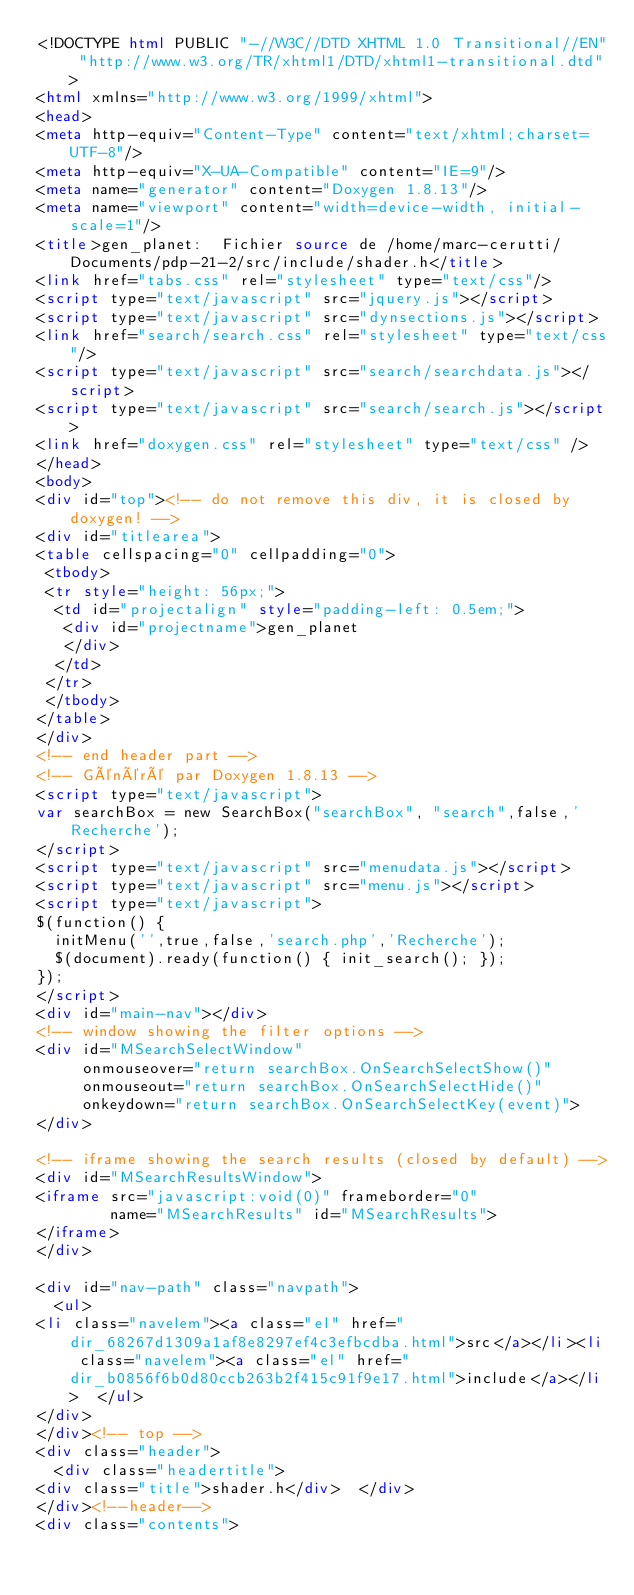<code> <loc_0><loc_0><loc_500><loc_500><_HTML_><!DOCTYPE html PUBLIC "-//W3C//DTD XHTML 1.0 Transitional//EN" "http://www.w3.org/TR/xhtml1/DTD/xhtml1-transitional.dtd">
<html xmlns="http://www.w3.org/1999/xhtml">
<head>
<meta http-equiv="Content-Type" content="text/xhtml;charset=UTF-8"/>
<meta http-equiv="X-UA-Compatible" content="IE=9"/>
<meta name="generator" content="Doxygen 1.8.13"/>
<meta name="viewport" content="width=device-width, initial-scale=1"/>
<title>gen_planet:  Fichier source de /home/marc-cerutti/Documents/pdp-21-2/src/include/shader.h</title>
<link href="tabs.css" rel="stylesheet" type="text/css"/>
<script type="text/javascript" src="jquery.js"></script>
<script type="text/javascript" src="dynsections.js"></script>
<link href="search/search.css" rel="stylesheet" type="text/css"/>
<script type="text/javascript" src="search/searchdata.js"></script>
<script type="text/javascript" src="search/search.js"></script>
<link href="doxygen.css" rel="stylesheet" type="text/css" />
</head>
<body>
<div id="top"><!-- do not remove this div, it is closed by doxygen! -->
<div id="titlearea">
<table cellspacing="0" cellpadding="0">
 <tbody>
 <tr style="height: 56px;">
  <td id="projectalign" style="padding-left: 0.5em;">
   <div id="projectname">gen_planet
   </div>
  </td>
 </tr>
 </tbody>
</table>
</div>
<!-- end header part -->
<!-- Généré par Doxygen 1.8.13 -->
<script type="text/javascript">
var searchBox = new SearchBox("searchBox", "search",false,'Recherche');
</script>
<script type="text/javascript" src="menudata.js"></script>
<script type="text/javascript" src="menu.js"></script>
<script type="text/javascript">
$(function() {
  initMenu('',true,false,'search.php','Recherche');
  $(document).ready(function() { init_search(); });
});
</script>
<div id="main-nav"></div>
<!-- window showing the filter options -->
<div id="MSearchSelectWindow"
     onmouseover="return searchBox.OnSearchSelectShow()"
     onmouseout="return searchBox.OnSearchSelectHide()"
     onkeydown="return searchBox.OnSearchSelectKey(event)">
</div>

<!-- iframe showing the search results (closed by default) -->
<div id="MSearchResultsWindow">
<iframe src="javascript:void(0)" frameborder="0" 
        name="MSearchResults" id="MSearchResults">
</iframe>
</div>

<div id="nav-path" class="navpath">
  <ul>
<li class="navelem"><a class="el" href="dir_68267d1309a1af8e8297ef4c3efbcdba.html">src</a></li><li class="navelem"><a class="el" href="dir_b0856f6b0d80ccb263b2f415c91f9e17.html">include</a></li>  </ul>
</div>
</div><!-- top -->
<div class="header">
  <div class="headertitle">
<div class="title">shader.h</div>  </div>
</div><!--header-->
<div class="contents"></code> 